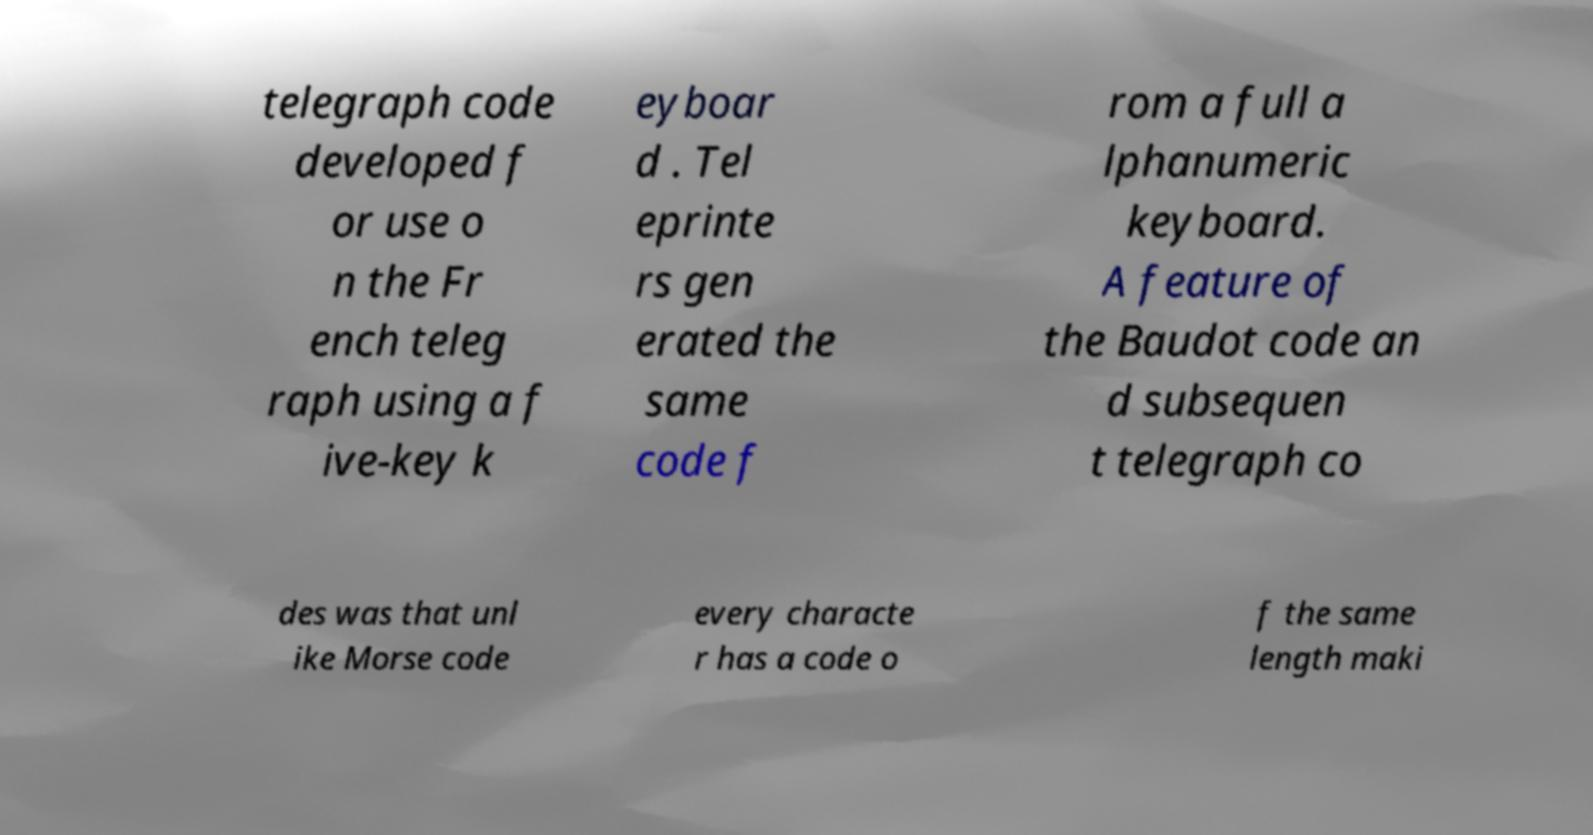Could you assist in decoding the text presented in this image and type it out clearly? telegraph code developed f or use o n the Fr ench teleg raph using a f ive-key k eyboar d . Tel eprinte rs gen erated the same code f rom a full a lphanumeric keyboard. A feature of the Baudot code an d subsequen t telegraph co des was that unl ike Morse code every characte r has a code o f the same length maki 